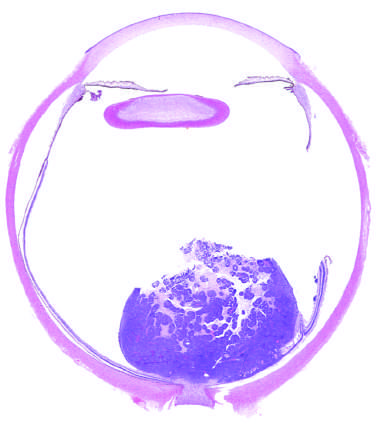what is the poorly cohesive tumor in the retina seen abutting?
Answer the question using a single word or phrase. The optic nerve 